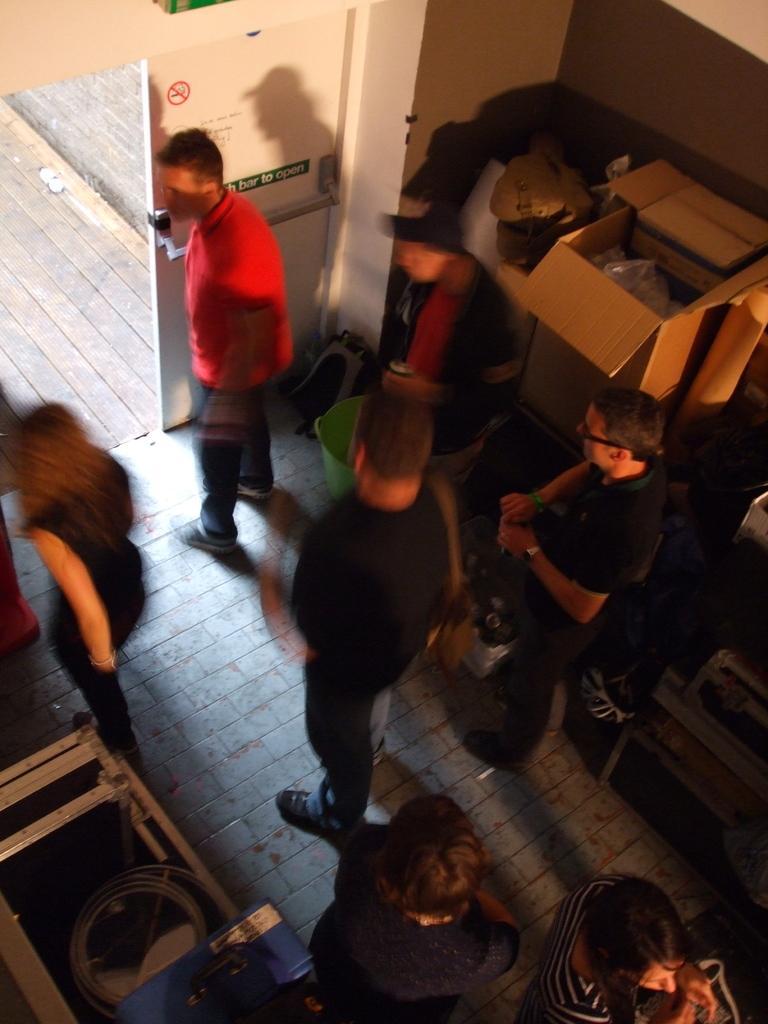Please provide a concise description of this image. In this image we can see this part is blurred, where we can see these people are walking on the floor, here we can see some objects, cardboard box, backpack, dustbin, door and the road. 